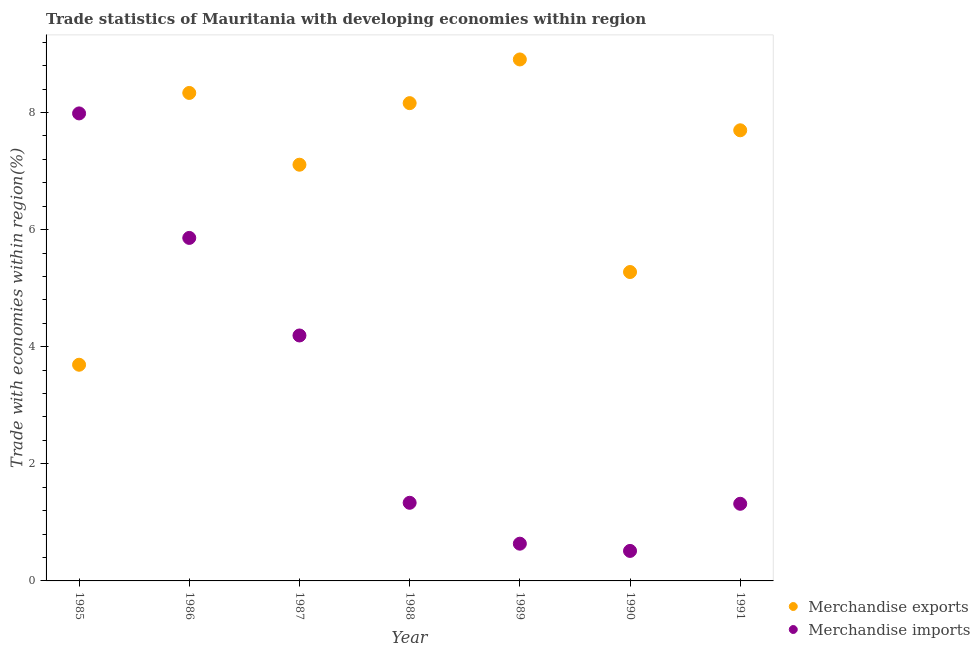Is the number of dotlines equal to the number of legend labels?
Your response must be concise. Yes. What is the merchandise exports in 1985?
Your answer should be compact. 3.69. Across all years, what is the maximum merchandise exports?
Provide a short and direct response. 8.91. Across all years, what is the minimum merchandise exports?
Offer a very short reply. 3.69. In which year was the merchandise exports maximum?
Your response must be concise. 1989. In which year was the merchandise exports minimum?
Keep it short and to the point. 1985. What is the total merchandise imports in the graph?
Your answer should be compact. 21.84. What is the difference between the merchandise exports in 1988 and that in 1989?
Make the answer very short. -0.75. What is the difference between the merchandise imports in 1990 and the merchandise exports in 1986?
Provide a short and direct response. -7.82. What is the average merchandise exports per year?
Give a very brief answer. 7.03. In the year 1985, what is the difference between the merchandise imports and merchandise exports?
Make the answer very short. 4.29. What is the ratio of the merchandise imports in 1987 to that in 1988?
Offer a very short reply. 3.14. What is the difference between the highest and the second highest merchandise exports?
Give a very brief answer. 0.57. What is the difference between the highest and the lowest merchandise imports?
Provide a short and direct response. 7.47. In how many years, is the merchandise exports greater than the average merchandise exports taken over all years?
Offer a very short reply. 5. Does the merchandise imports monotonically increase over the years?
Provide a succinct answer. No. Is the merchandise exports strictly greater than the merchandise imports over the years?
Offer a very short reply. No. Is the merchandise exports strictly less than the merchandise imports over the years?
Your answer should be very brief. No. Are the values on the major ticks of Y-axis written in scientific E-notation?
Your answer should be very brief. No. What is the title of the graph?
Your answer should be very brief. Trade statistics of Mauritania with developing economies within region. What is the label or title of the Y-axis?
Provide a succinct answer. Trade with economies within region(%). What is the Trade with economies within region(%) of Merchandise exports in 1985?
Provide a short and direct response. 3.69. What is the Trade with economies within region(%) in Merchandise imports in 1985?
Make the answer very short. 7.98. What is the Trade with economies within region(%) in Merchandise exports in 1986?
Offer a terse response. 8.33. What is the Trade with economies within region(%) in Merchandise imports in 1986?
Make the answer very short. 5.86. What is the Trade with economies within region(%) of Merchandise exports in 1987?
Provide a succinct answer. 7.11. What is the Trade with economies within region(%) of Merchandise imports in 1987?
Your response must be concise. 4.19. What is the Trade with economies within region(%) of Merchandise exports in 1988?
Your answer should be very brief. 8.16. What is the Trade with economies within region(%) in Merchandise imports in 1988?
Your answer should be compact. 1.33. What is the Trade with economies within region(%) of Merchandise exports in 1989?
Offer a terse response. 8.91. What is the Trade with economies within region(%) of Merchandise imports in 1989?
Offer a terse response. 0.64. What is the Trade with economies within region(%) in Merchandise exports in 1990?
Make the answer very short. 5.28. What is the Trade with economies within region(%) of Merchandise imports in 1990?
Ensure brevity in your answer.  0.51. What is the Trade with economies within region(%) in Merchandise exports in 1991?
Offer a very short reply. 7.7. What is the Trade with economies within region(%) of Merchandise imports in 1991?
Provide a short and direct response. 1.32. Across all years, what is the maximum Trade with economies within region(%) of Merchandise exports?
Offer a very short reply. 8.91. Across all years, what is the maximum Trade with economies within region(%) in Merchandise imports?
Provide a succinct answer. 7.98. Across all years, what is the minimum Trade with economies within region(%) in Merchandise exports?
Your response must be concise. 3.69. Across all years, what is the minimum Trade with economies within region(%) of Merchandise imports?
Ensure brevity in your answer.  0.51. What is the total Trade with economies within region(%) of Merchandise exports in the graph?
Offer a terse response. 49.18. What is the total Trade with economies within region(%) in Merchandise imports in the graph?
Your answer should be very brief. 21.84. What is the difference between the Trade with economies within region(%) in Merchandise exports in 1985 and that in 1986?
Your response must be concise. -4.64. What is the difference between the Trade with economies within region(%) in Merchandise imports in 1985 and that in 1986?
Provide a short and direct response. 2.13. What is the difference between the Trade with economies within region(%) in Merchandise exports in 1985 and that in 1987?
Give a very brief answer. -3.42. What is the difference between the Trade with economies within region(%) in Merchandise imports in 1985 and that in 1987?
Provide a succinct answer. 3.79. What is the difference between the Trade with economies within region(%) of Merchandise exports in 1985 and that in 1988?
Offer a very short reply. -4.47. What is the difference between the Trade with economies within region(%) in Merchandise imports in 1985 and that in 1988?
Your answer should be compact. 6.65. What is the difference between the Trade with economies within region(%) in Merchandise exports in 1985 and that in 1989?
Your response must be concise. -5.21. What is the difference between the Trade with economies within region(%) in Merchandise imports in 1985 and that in 1989?
Your response must be concise. 7.35. What is the difference between the Trade with economies within region(%) in Merchandise exports in 1985 and that in 1990?
Give a very brief answer. -1.58. What is the difference between the Trade with economies within region(%) of Merchandise imports in 1985 and that in 1990?
Your answer should be compact. 7.47. What is the difference between the Trade with economies within region(%) of Merchandise exports in 1985 and that in 1991?
Your answer should be very brief. -4. What is the difference between the Trade with economies within region(%) of Merchandise imports in 1985 and that in 1991?
Give a very brief answer. 6.67. What is the difference between the Trade with economies within region(%) in Merchandise exports in 1986 and that in 1987?
Make the answer very short. 1.23. What is the difference between the Trade with economies within region(%) of Merchandise imports in 1986 and that in 1987?
Keep it short and to the point. 1.67. What is the difference between the Trade with economies within region(%) of Merchandise exports in 1986 and that in 1988?
Make the answer very short. 0.17. What is the difference between the Trade with economies within region(%) of Merchandise imports in 1986 and that in 1988?
Give a very brief answer. 4.52. What is the difference between the Trade with economies within region(%) in Merchandise exports in 1986 and that in 1989?
Provide a short and direct response. -0.57. What is the difference between the Trade with economies within region(%) of Merchandise imports in 1986 and that in 1989?
Your answer should be very brief. 5.22. What is the difference between the Trade with economies within region(%) in Merchandise exports in 1986 and that in 1990?
Provide a short and direct response. 3.06. What is the difference between the Trade with economies within region(%) of Merchandise imports in 1986 and that in 1990?
Your response must be concise. 5.35. What is the difference between the Trade with economies within region(%) of Merchandise exports in 1986 and that in 1991?
Offer a terse response. 0.64. What is the difference between the Trade with economies within region(%) in Merchandise imports in 1986 and that in 1991?
Provide a short and direct response. 4.54. What is the difference between the Trade with economies within region(%) in Merchandise exports in 1987 and that in 1988?
Your answer should be compact. -1.05. What is the difference between the Trade with economies within region(%) of Merchandise imports in 1987 and that in 1988?
Provide a succinct answer. 2.86. What is the difference between the Trade with economies within region(%) of Merchandise exports in 1987 and that in 1989?
Offer a terse response. -1.8. What is the difference between the Trade with economies within region(%) of Merchandise imports in 1987 and that in 1989?
Your response must be concise. 3.56. What is the difference between the Trade with economies within region(%) of Merchandise exports in 1987 and that in 1990?
Give a very brief answer. 1.83. What is the difference between the Trade with economies within region(%) in Merchandise imports in 1987 and that in 1990?
Offer a very short reply. 3.68. What is the difference between the Trade with economies within region(%) in Merchandise exports in 1987 and that in 1991?
Your answer should be compact. -0.59. What is the difference between the Trade with economies within region(%) of Merchandise imports in 1987 and that in 1991?
Your answer should be very brief. 2.87. What is the difference between the Trade with economies within region(%) in Merchandise exports in 1988 and that in 1989?
Your answer should be very brief. -0.75. What is the difference between the Trade with economies within region(%) in Merchandise imports in 1988 and that in 1989?
Offer a very short reply. 0.7. What is the difference between the Trade with economies within region(%) in Merchandise exports in 1988 and that in 1990?
Your answer should be compact. 2.88. What is the difference between the Trade with economies within region(%) of Merchandise imports in 1988 and that in 1990?
Your answer should be very brief. 0.82. What is the difference between the Trade with economies within region(%) in Merchandise exports in 1988 and that in 1991?
Offer a terse response. 0.46. What is the difference between the Trade with economies within region(%) in Merchandise imports in 1988 and that in 1991?
Offer a very short reply. 0.02. What is the difference between the Trade with economies within region(%) of Merchandise exports in 1989 and that in 1990?
Keep it short and to the point. 3.63. What is the difference between the Trade with economies within region(%) of Merchandise imports in 1989 and that in 1990?
Give a very brief answer. 0.12. What is the difference between the Trade with economies within region(%) of Merchandise exports in 1989 and that in 1991?
Offer a very short reply. 1.21. What is the difference between the Trade with economies within region(%) of Merchandise imports in 1989 and that in 1991?
Ensure brevity in your answer.  -0.68. What is the difference between the Trade with economies within region(%) of Merchandise exports in 1990 and that in 1991?
Give a very brief answer. -2.42. What is the difference between the Trade with economies within region(%) of Merchandise imports in 1990 and that in 1991?
Keep it short and to the point. -0.81. What is the difference between the Trade with economies within region(%) of Merchandise exports in 1985 and the Trade with economies within region(%) of Merchandise imports in 1986?
Give a very brief answer. -2.17. What is the difference between the Trade with economies within region(%) of Merchandise exports in 1985 and the Trade with economies within region(%) of Merchandise imports in 1987?
Your response must be concise. -0.5. What is the difference between the Trade with economies within region(%) in Merchandise exports in 1985 and the Trade with economies within region(%) in Merchandise imports in 1988?
Your answer should be very brief. 2.36. What is the difference between the Trade with economies within region(%) of Merchandise exports in 1985 and the Trade with economies within region(%) of Merchandise imports in 1989?
Your answer should be compact. 3.06. What is the difference between the Trade with economies within region(%) of Merchandise exports in 1985 and the Trade with economies within region(%) of Merchandise imports in 1990?
Provide a short and direct response. 3.18. What is the difference between the Trade with economies within region(%) of Merchandise exports in 1985 and the Trade with economies within region(%) of Merchandise imports in 1991?
Your answer should be compact. 2.37. What is the difference between the Trade with economies within region(%) in Merchandise exports in 1986 and the Trade with economies within region(%) in Merchandise imports in 1987?
Make the answer very short. 4.14. What is the difference between the Trade with economies within region(%) of Merchandise exports in 1986 and the Trade with economies within region(%) of Merchandise imports in 1988?
Your answer should be very brief. 7. What is the difference between the Trade with economies within region(%) in Merchandise exports in 1986 and the Trade with economies within region(%) in Merchandise imports in 1989?
Your answer should be very brief. 7.7. What is the difference between the Trade with economies within region(%) in Merchandise exports in 1986 and the Trade with economies within region(%) in Merchandise imports in 1990?
Your answer should be very brief. 7.82. What is the difference between the Trade with economies within region(%) in Merchandise exports in 1986 and the Trade with economies within region(%) in Merchandise imports in 1991?
Ensure brevity in your answer.  7.02. What is the difference between the Trade with economies within region(%) of Merchandise exports in 1987 and the Trade with economies within region(%) of Merchandise imports in 1988?
Your answer should be very brief. 5.77. What is the difference between the Trade with economies within region(%) in Merchandise exports in 1987 and the Trade with economies within region(%) in Merchandise imports in 1989?
Offer a terse response. 6.47. What is the difference between the Trade with economies within region(%) in Merchandise exports in 1987 and the Trade with economies within region(%) in Merchandise imports in 1990?
Ensure brevity in your answer.  6.6. What is the difference between the Trade with economies within region(%) in Merchandise exports in 1987 and the Trade with economies within region(%) in Merchandise imports in 1991?
Your answer should be very brief. 5.79. What is the difference between the Trade with economies within region(%) in Merchandise exports in 1988 and the Trade with economies within region(%) in Merchandise imports in 1989?
Offer a terse response. 7.52. What is the difference between the Trade with economies within region(%) of Merchandise exports in 1988 and the Trade with economies within region(%) of Merchandise imports in 1990?
Provide a succinct answer. 7.65. What is the difference between the Trade with economies within region(%) in Merchandise exports in 1988 and the Trade with economies within region(%) in Merchandise imports in 1991?
Give a very brief answer. 6.84. What is the difference between the Trade with economies within region(%) of Merchandise exports in 1989 and the Trade with economies within region(%) of Merchandise imports in 1990?
Provide a succinct answer. 8.39. What is the difference between the Trade with economies within region(%) in Merchandise exports in 1989 and the Trade with economies within region(%) in Merchandise imports in 1991?
Offer a terse response. 7.59. What is the difference between the Trade with economies within region(%) in Merchandise exports in 1990 and the Trade with economies within region(%) in Merchandise imports in 1991?
Provide a succinct answer. 3.96. What is the average Trade with economies within region(%) of Merchandise exports per year?
Offer a terse response. 7.03. What is the average Trade with economies within region(%) in Merchandise imports per year?
Provide a short and direct response. 3.12. In the year 1985, what is the difference between the Trade with economies within region(%) in Merchandise exports and Trade with economies within region(%) in Merchandise imports?
Your answer should be compact. -4.29. In the year 1986, what is the difference between the Trade with economies within region(%) in Merchandise exports and Trade with economies within region(%) in Merchandise imports?
Offer a very short reply. 2.48. In the year 1987, what is the difference between the Trade with economies within region(%) in Merchandise exports and Trade with economies within region(%) in Merchandise imports?
Your answer should be compact. 2.92. In the year 1988, what is the difference between the Trade with economies within region(%) in Merchandise exports and Trade with economies within region(%) in Merchandise imports?
Offer a very short reply. 6.83. In the year 1989, what is the difference between the Trade with economies within region(%) in Merchandise exports and Trade with economies within region(%) in Merchandise imports?
Your response must be concise. 8.27. In the year 1990, what is the difference between the Trade with economies within region(%) in Merchandise exports and Trade with economies within region(%) in Merchandise imports?
Your answer should be very brief. 4.76. In the year 1991, what is the difference between the Trade with economies within region(%) in Merchandise exports and Trade with economies within region(%) in Merchandise imports?
Provide a short and direct response. 6.38. What is the ratio of the Trade with economies within region(%) in Merchandise exports in 1985 to that in 1986?
Give a very brief answer. 0.44. What is the ratio of the Trade with economies within region(%) of Merchandise imports in 1985 to that in 1986?
Give a very brief answer. 1.36. What is the ratio of the Trade with economies within region(%) in Merchandise exports in 1985 to that in 1987?
Make the answer very short. 0.52. What is the ratio of the Trade with economies within region(%) in Merchandise imports in 1985 to that in 1987?
Provide a short and direct response. 1.9. What is the ratio of the Trade with economies within region(%) of Merchandise exports in 1985 to that in 1988?
Offer a terse response. 0.45. What is the ratio of the Trade with economies within region(%) in Merchandise imports in 1985 to that in 1988?
Make the answer very short. 5.98. What is the ratio of the Trade with economies within region(%) in Merchandise exports in 1985 to that in 1989?
Your answer should be compact. 0.41. What is the ratio of the Trade with economies within region(%) of Merchandise imports in 1985 to that in 1989?
Make the answer very short. 12.56. What is the ratio of the Trade with economies within region(%) in Merchandise exports in 1985 to that in 1990?
Your answer should be very brief. 0.7. What is the ratio of the Trade with economies within region(%) of Merchandise imports in 1985 to that in 1990?
Keep it short and to the point. 15.58. What is the ratio of the Trade with economies within region(%) of Merchandise exports in 1985 to that in 1991?
Make the answer very short. 0.48. What is the ratio of the Trade with economies within region(%) of Merchandise imports in 1985 to that in 1991?
Offer a terse response. 6.06. What is the ratio of the Trade with economies within region(%) in Merchandise exports in 1986 to that in 1987?
Give a very brief answer. 1.17. What is the ratio of the Trade with economies within region(%) in Merchandise imports in 1986 to that in 1987?
Your response must be concise. 1.4. What is the ratio of the Trade with economies within region(%) of Merchandise exports in 1986 to that in 1988?
Provide a succinct answer. 1.02. What is the ratio of the Trade with economies within region(%) in Merchandise imports in 1986 to that in 1988?
Your answer should be very brief. 4.39. What is the ratio of the Trade with economies within region(%) of Merchandise exports in 1986 to that in 1989?
Provide a short and direct response. 0.94. What is the ratio of the Trade with economies within region(%) in Merchandise imports in 1986 to that in 1989?
Your answer should be very brief. 9.21. What is the ratio of the Trade with economies within region(%) in Merchandise exports in 1986 to that in 1990?
Your response must be concise. 1.58. What is the ratio of the Trade with economies within region(%) of Merchandise imports in 1986 to that in 1990?
Your answer should be compact. 11.43. What is the ratio of the Trade with economies within region(%) of Merchandise exports in 1986 to that in 1991?
Your answer should be very brief. 1.08. What is the ratio of the Trade with economies within region(%) in Merchandise imports in 1986 to that in 1991?
Provide a short and direct response. 4.45. What is the ratio of the Trade with economies within region(%) of Merchandise exports in 1987 to that in 1988?
Provide a short and direct response. 0.87. What is the ratio of the Trade with economies within region(%) in Merchandise imports in 1987 to that in 1988?
Provide a short and direct response. 3.14. What is the ratio of the Trade with economies within region(%) of Merchandise exports in 1987 to that in 1989?
Your response must be concise. 0.8. What is the ratio of the Trade with economies within region(%) in Merchandise imports in 1987 to that in 1989?
Offer a very short reply. 6.59. What is the ratio of the Trade with economies within region(%) in Merchandise exports in 1987 to that in 1990?
Make the answer very short. 1.35. What is the ratio of the Trade with economies within region(%) in Merchandise imports in 1987 to that in 1990?
Make the answer very short. 8.18. What is the ratio of the Trade with economies within region(%) of Merchandise exports in 1987 to that in 1991?
Provide a short and direct response. 0.92. What is the ratio of the Trade with economies within region(%) in Merchandise imports in 1987 to that in 1991?
Ensure brevity in your answer.  3.18. What is the ratio of the Trade with economies within region(%) of Merchandise exports in 1988 to that in 1989?
Make the answer very short. 0.92. What is the ratio of the Trade with economies within region(%) in Merchandise imports in 1988 to that in 1989?
Offer a terse response. 2.1. What is the ratio of the Trade with economies within region(%) in Merchandise exports in 1988 to that in 1990?
Offer a very short reply. 1.55. What is the ratio of the Trade with economies within region(%) of Merchandise imports in 1988 to that in 1990?
Make the answer very short. 2.6. What is the ratio of the Trade with economies within region(%) of Merchandise exports in 1988 to that in 1991?
Ensure brevity in your answer.  1.06. What is the ratio of the Trade with economies within region(%) of Merchandise imports in 1988 to that in 1991?
Offer a terse response. 1.01. What is the ratio of the Trade with economies within region(%) of Merchandise exports in 1989 to that in 1990?
Offer a terse response. 1.69. What is the ratio of the Trade with economies within region(%) in Merchandise imports in 1989 to that in 1990?
Keep it short and to the point. 1.24. What is the ratio of the Trade with economies within region(%) in Merchandise exports in 1989 to that in 1991?
Offer a terse response. 1.16. What is the ratio of the Trade with economies within region(%) in Merchandise imports in 1989 to that in 1991?
Make the answer very short. 0.48. What is the ratio of the Trade with economies within region(%) of Merchandise exports in 1990 to that in 1991?
Offer a terse response. 0.69. What is the ratio of the Trade with economies within region(%) of Merchandise imports in 1990 to that in 1991?
Keep it short and to the point. 0.39. What is the difference between the highest and the second highest Trade with economies within region(%) of Merchandise exports?
Provide a short and direct response. 0.57. What is the difference between the highest and the second highest Trade with economies within region(%) in Merchandise imports?
Make the answer very short. 2.13. What is the difference between the highest and the lowest Trade with economies within region(%) in Merchandise exports?
Your answer should be very brief. 5.21. What is the difference between the highest and the lowest Trade with economies within region(%) in Merchandise imports?
Offer a very short reply. 7.47. 